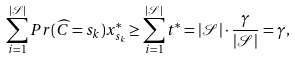<formula> <loc_0><loc_0><loc_500><loc_500>\sum _ { i = 1 } ^ { | \mathcal { S } | } P r ( \widehat { C } = s _ { k } ) x _ { s _ { k } } ^ { * } \geq \sum _ { i = 1 } ^ { | \mathcal { S } | } t ^ { * } = | \mathcal { S } | \cdot \frac { \gamma } { | \mathcal { S } | } = \gamma ,</formula> 